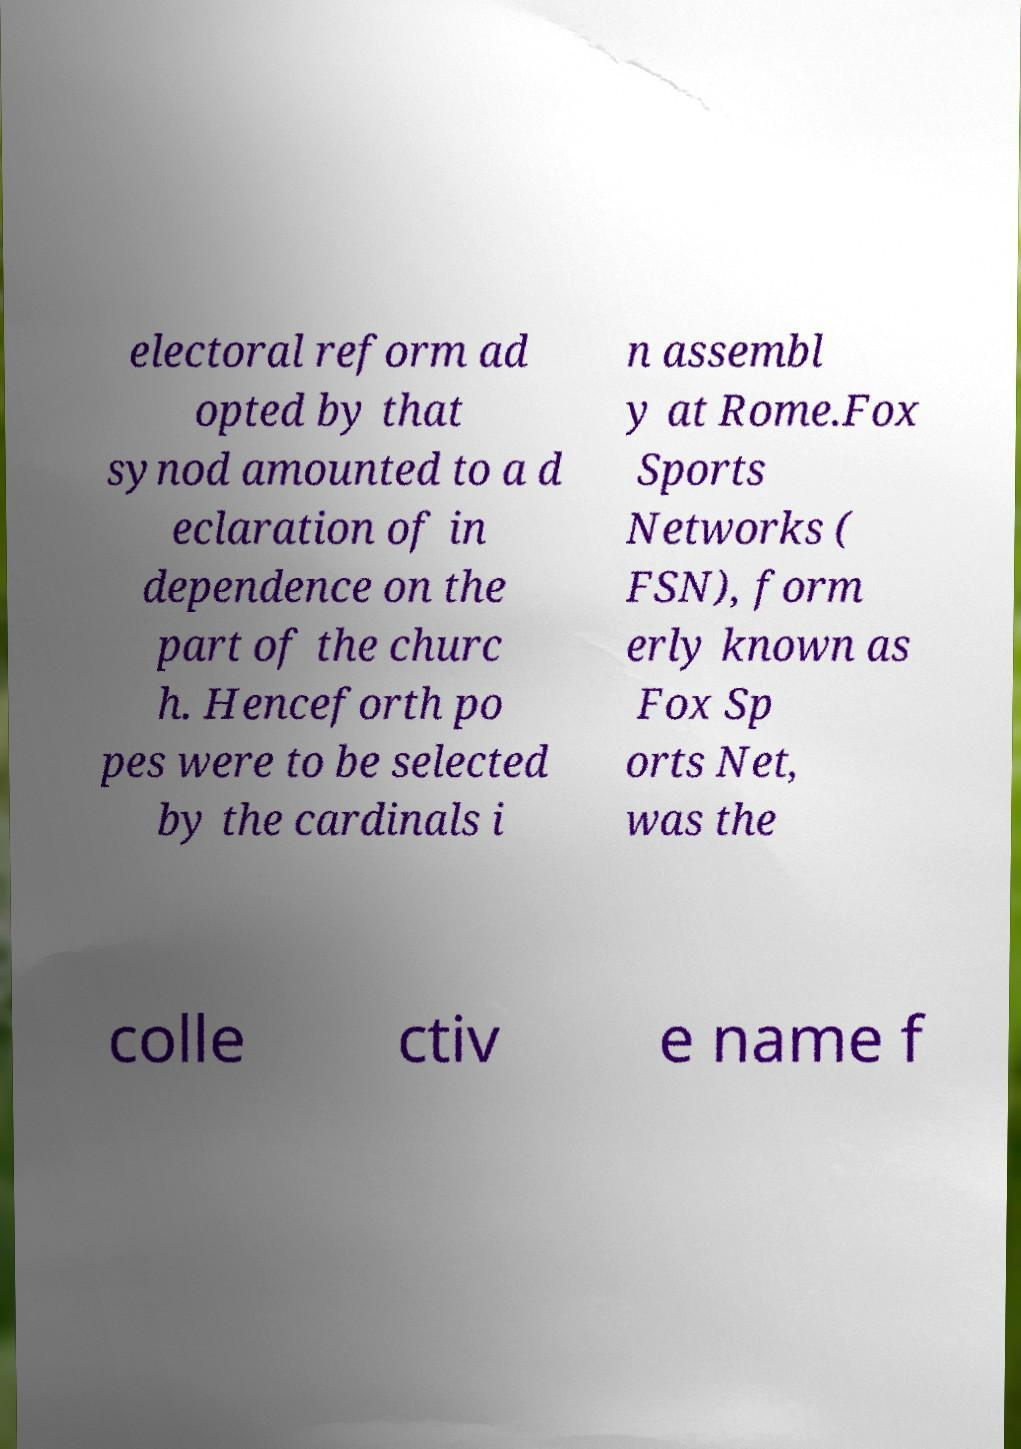Please identify and transcribe the text found in this image. electoral reform ad opted by that synod amounted to a d eclaration of in dependence on the part of the churc h. Henceforth po pes were to be selected by the cardinals i n assembl y at Rome.Fox Sports Networks ( FSN), form erly known as Fox Sp orts Net, was the colle ctiv e name f 